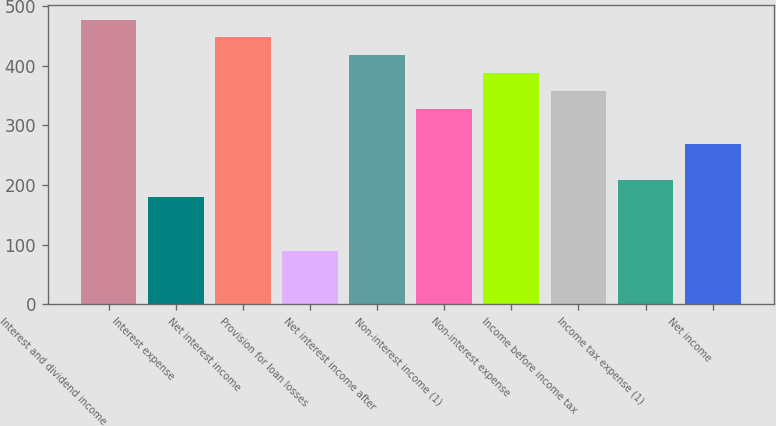Convert chart to OTSL. <chart><loc_0><loc_0><loc_500><loc_500><bar_chart><fcel>Interest and dividend income<fcel>Interest expense<fcel>Net interest income<fcel>Provision for loan losses<fcel>Net interest income after<fcel>Non-interest income (1)<fcel>Non-interest expense<fcel>Income before income tax<fcel>Income tax expense (1)<fcel>Net income<nl><fcel>477.77<fcel>179.27<fcel>447.92<fcel>89.72<fcel>418.07<fcel>328.52<fcel>388.22<fcel>358.37<fcel>209.12<fcel>268.82<nl></chart> 